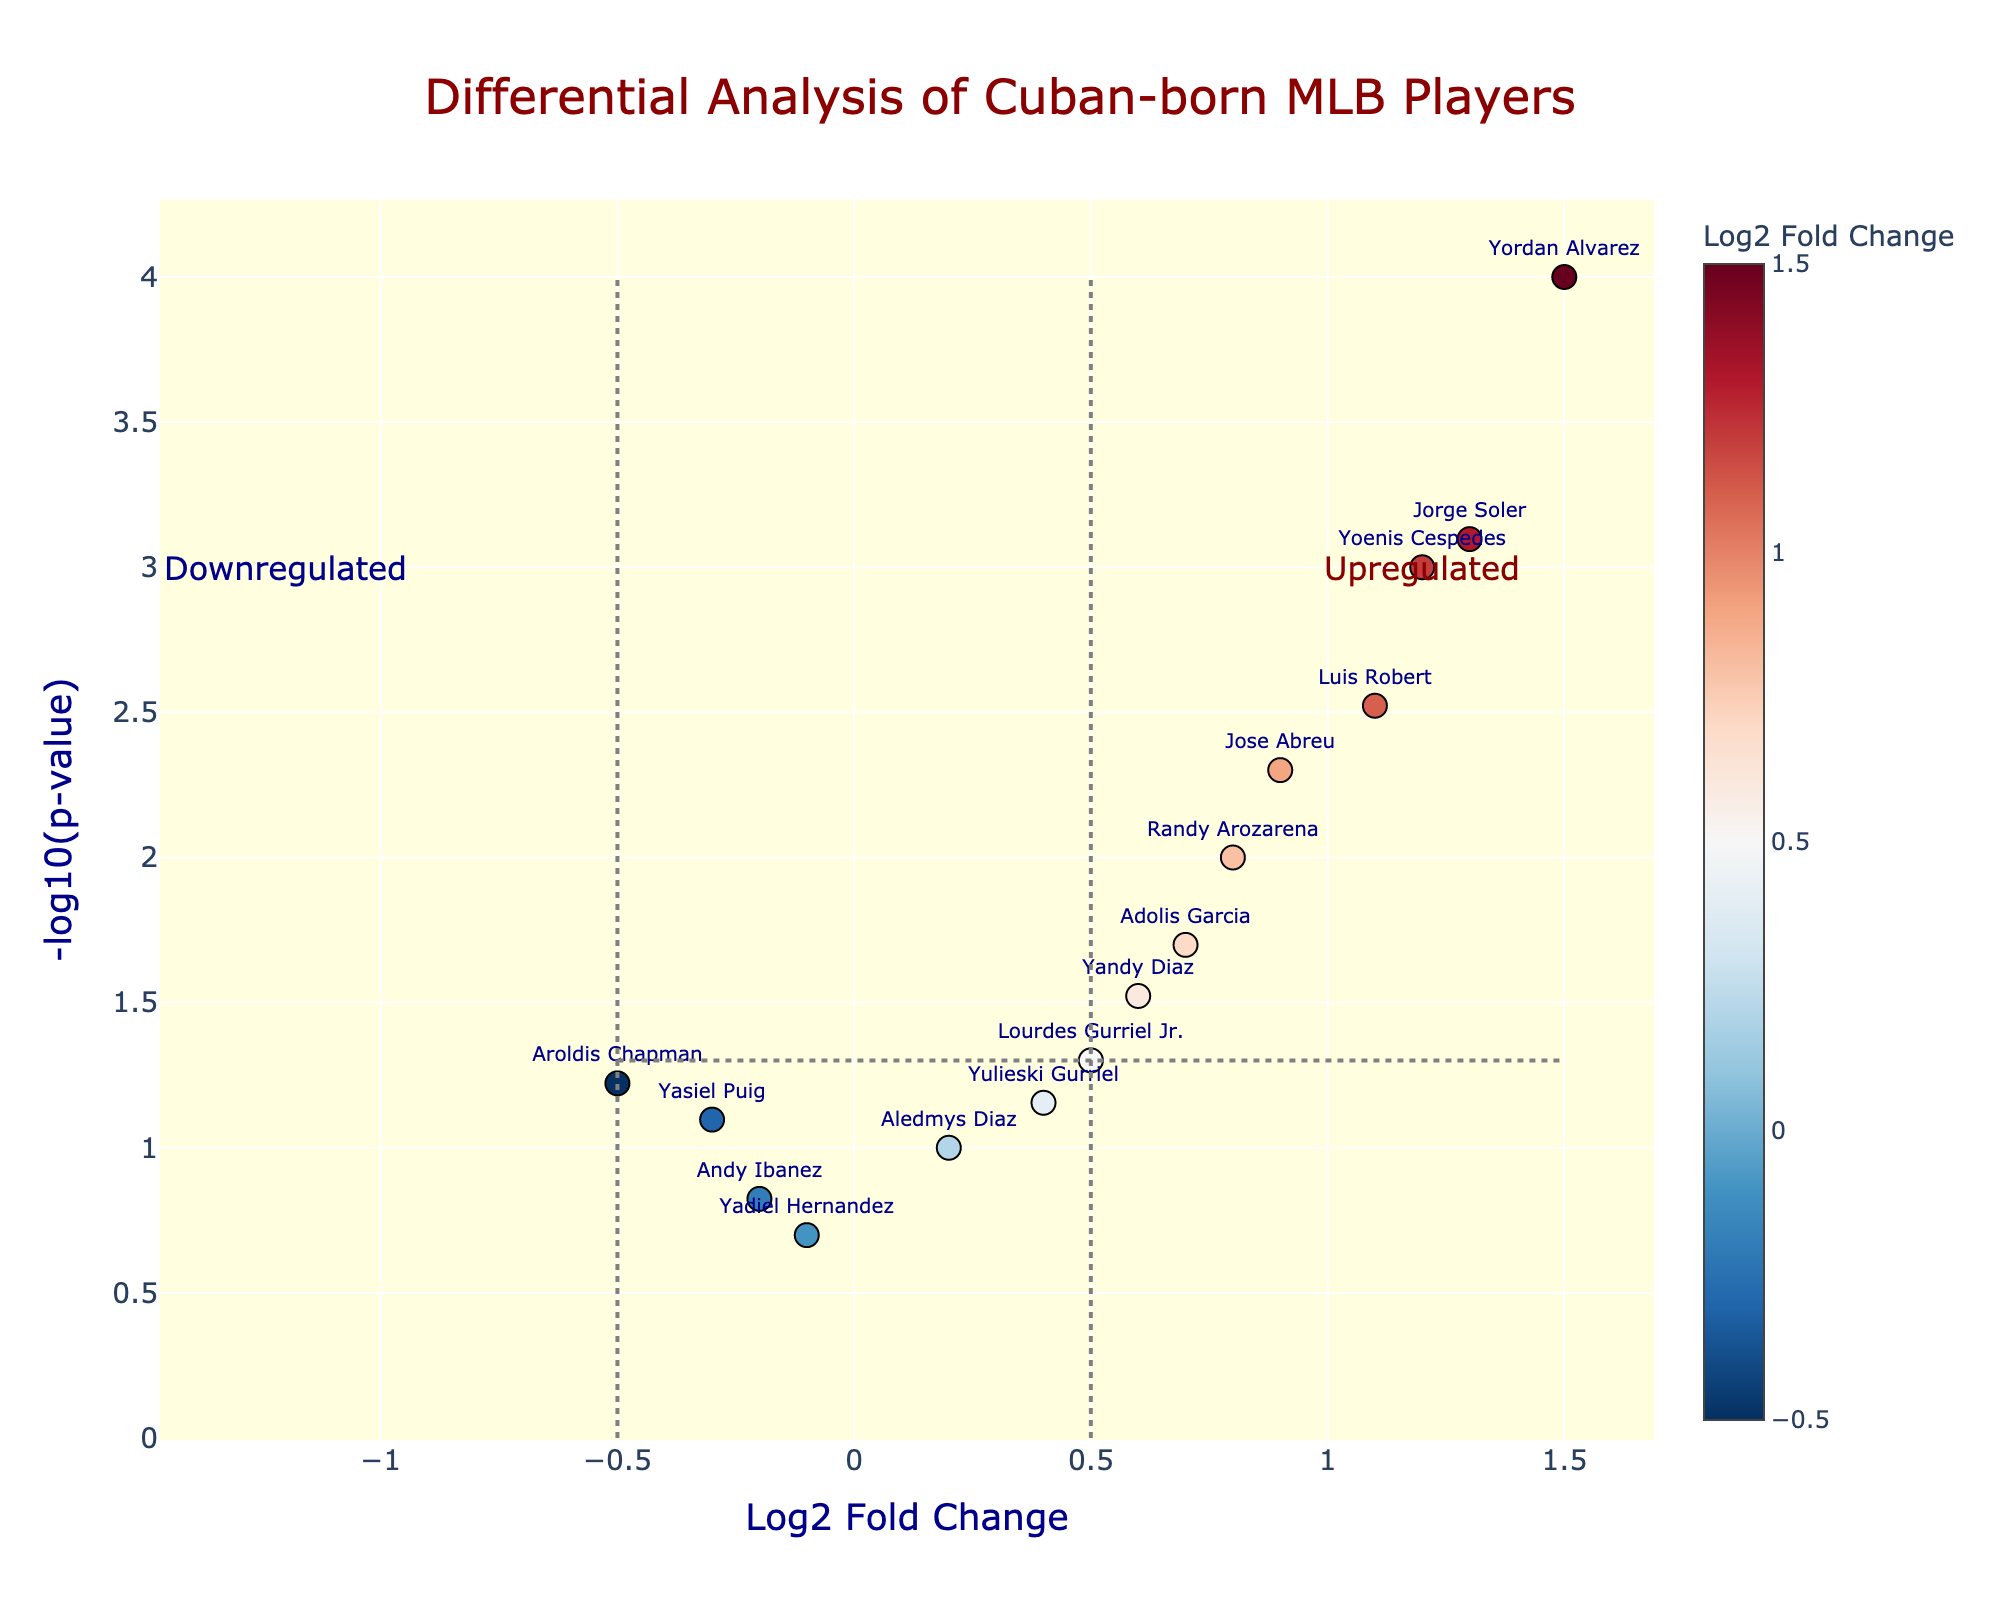How many players are represented in the plot? Count the number of data points or player names shown in the figure's scatter plot.
Answer: 15 Which player has the highest Log2 Fold Change? The player with the highest Log2 Fold Change will be the one with the rightmost data point in the scatter plot.
Answer: Yordan Alvarez What is the significance threshold indicated by the horizontal line? The horizontal line represents the -log10(0.05) significance threshold, which can be identified by observing the y-coordinate of the horizontal line.
Answer: 1.3 How many players have a p-value less than 0.05? Count the number of data points above the horizontal threshold line, since these data points have a y-value greater than 1.3 (i.e., -log10(p-value) > 1.3).
Answer: 8 Which player has the lowest p-value? The player with the lowest p-value will have the highest y-coordinate in the scatter plot.
Answer: Yordan Alvarez How many players have a Log2 Fold Change greater than 0.5 and a p-value less than 0.05? Count the number of data points that are both to the right of the vertical line at x=0.5 and above the horizontal line at y=1.3.
Answer: 6 Which players are considered downregulated? Identify the players whose data points are to the left of the vertical threshold line at x=-0.5.
Answer: Yasiel Puig, Aroldis Chapman What are the Log2 Fold Changes and p-values of Adolis Garcia? Find Adolis Garcia's data point and read the values from the hover text or position.
Answer: Log2FC: 0.7, p-value: 0.02 Which players have Log2 Fold Changes between -0.5 and 0.5 with p-values greater than 0.05? Identify the data points within the vertical bounds -0.5 < x < 0.5 and beneath the horizontal line y=1.3, then read the player names.
Answer: Yulieski Gurriel, Aledmys Diaz, Yasiel Puig, Aroldis Chapman, Yadiel Hernandez, Andy Ibanez How many players have higher Log2 Fold Changes than Jose Abreu and also have p-values less than 0.01? Identify Jose Abreu's position first, then count the data points to the right of him and above the y=2 line (-log10(0.01)).
Answer: 4 